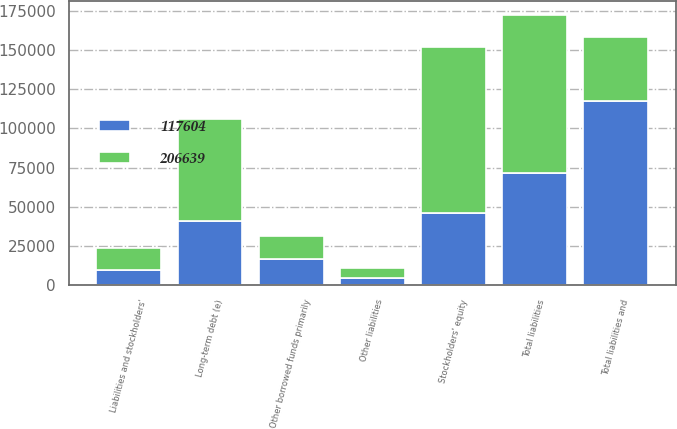Convert chart. <chart><loc_0><loc_0><loc_500><loc_500><stacked_bar_chart><ecel><fcel>Liabilities and stockholders'<fcel>Other borrowed funds primarily<fcel>Other liabilities<fcel>Long-term debt (e)<fcel>Total liabilities<fcel>Stockholders' equity<fcel>Total liabilities and<nl><fcel>206639<fcel>14195<fcel>15050<fcel>6309<fcel>65432<fcel>100986<fcel>105653<fcel>40635<nl><fcel>117604<fcel>9488<fcel>16560<fcel>4767<fcel>40635<fcel>71450<fcel>46154<fcel>117604<nl></chart> 